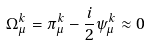<formula> <loc_0><loc_0><loc_500><loc_500>\Omega _ { \mu } ^ { k } = \pi _ { \mu } ^ { k } - \frac { i } { 2 } \psi _ { \mu } ^ { k } \approx 0</formula> 